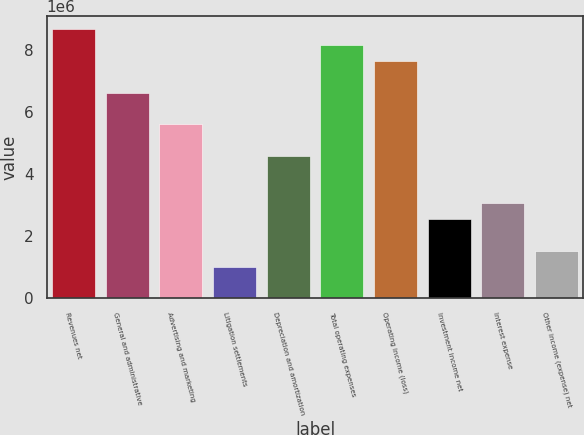Convert chart to OTSL. <chart><loc_0><loc_0><loc_500><loc_500><bar_chart><fcel>Revenues net<fcel>General and administrative<fcel>Advertising and marketing<fcel>Litigation settlements<fcel>Depreciation and amortization<fcel>Total operating expenses<fcel>Operating income (loss)<fcel>Investment income net<fcel>Interest expense<fcel>Other income (expense) net<nl><fcel>8.66775e+06<fcel>6.62829e+06<fcel>5.60855e+06<fcel>1.01975e+06<fcel>4.58882e+06<fcel>8.15789e+06<fcel>7.64802e+06<fcel>2.54935e+06<fcel>3.05921e+06<fcel>1.52961e+06<nl></chart> 